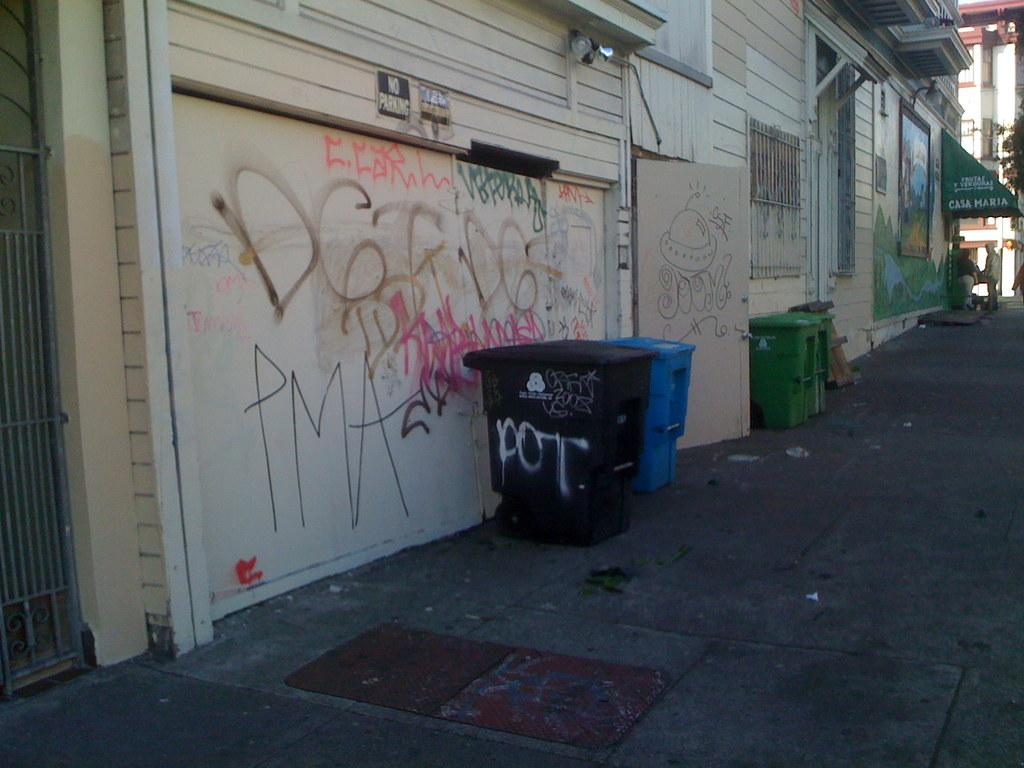<image>
Relay a brief, clear account of the picture shown. Black garbage can with the word POT on it. 